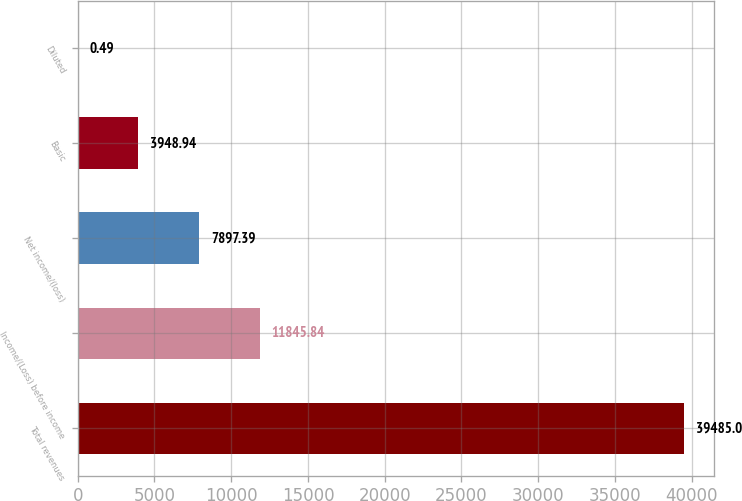<chart> <loc_0><loc_0><loc_500><loc_500><bar_chart><fcel>Total revenues<fcel>Income/(Loss) before income<fcel>Net income/(loss)<fcel>Basic<fcel>Diluted<nl><fcel>39485<fcel>11845.8<fcel>7897.39<fcel>3948.94<fcel>0.49<nl></chart> 